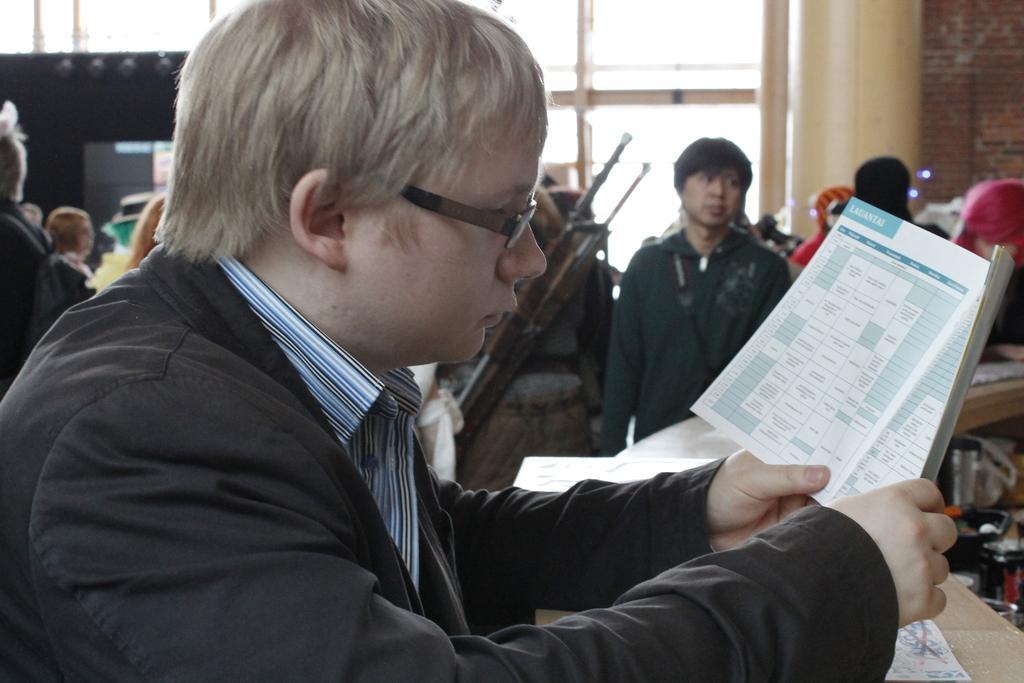Describe this image in one or two sentences. In this picture we can see a man wore a spectacle, blazer and holding a book with his hands and in the background we can see a group of people, some objects, wall. 